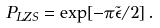Convert formula to latex. <formula><loc_0><loc_0><loc_500><loc_500>P _ { L Z S } = \exp [ { - { \pi \tilde { \epsilon } } / { 2 } } ] \, .</formula> 